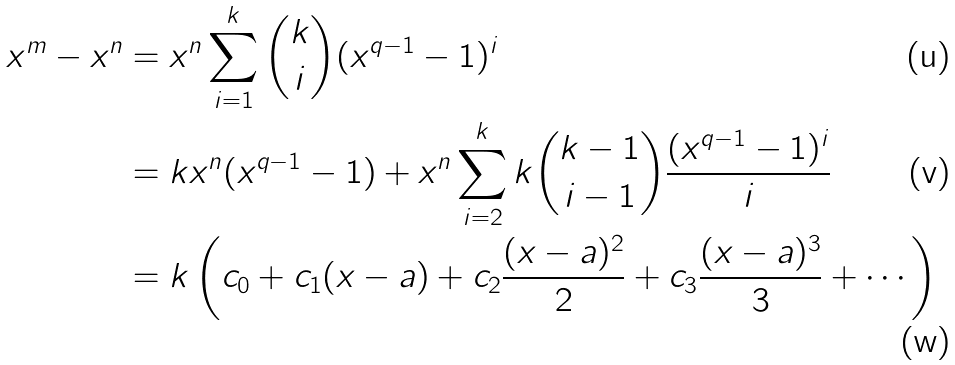Convert formula to latex. <formula><loc_0><loc_0><loc_500><loc_500>x ^ { m } - x ^ { n } & = x ^ { n } \sum _ { i = 1 } ^ { k } \binom { k } { i } ( x ^ { q - 1 } - 1 ) ^ { i } \\ & = k x ^ { n } ( x ^ { q - 1 } - 1 ) + x ^ { n } \sum _ { i = 2 } ^ { k } k \binom { k - 1 } { i - 1 } \frac { ( x ^ { q - 1 } - 1 ) ^ { i } } { i } \\ & = k \left ( c _ { 0 } + c _ { 1 } ( x - a ) + c _ { 2 } \frac { ( x - a ) ^ { 2 } } { 2 } + c _ { 3 } \frac { ( x - a ) ^ { 3 } } { 3 } + \cdots \right )</formula> 